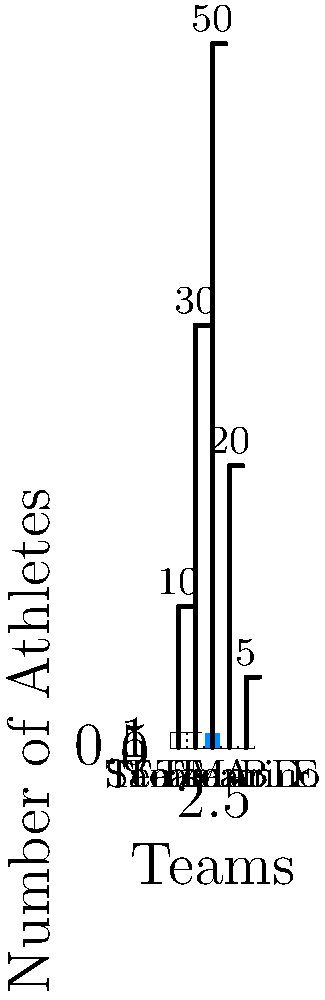In a collection of sports team photographs, how many athletes were identified as being from San Marino? To answer this question, we need to analyze the bar chart provided:

1. The chart shows the number of athletes from different teams.
2. Each bar represents a team, with the height of the bar indicating the number of athletes.
3. The teams are labeled A through E, with San Marino specifically identified.
4. The bar for San Marino is highlighted in blue, making it easy to distinguish.
5. By looking at the height of the San Marino bar, we can see it reaches 50.

Therefore, the number of athletes identified as being from San Marino is 50.
Answer: 50 